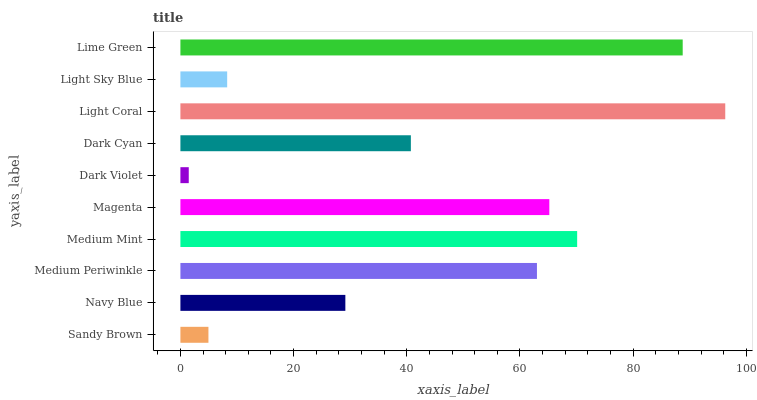Is Dark Violet the minimum?
Answer yes or no. Yes. Is Light Coral the maximum?
Answer yes or no. Yes. Is Navy Blue the minimum?
Answer yes or no. No. Is Navy Blue the maximum?
Answer yes or no. No. Is Navy Blue greater than Sandy Brown?
Answer yes or no. Yes. Is Sandy Brown less than Navy Blue?
Answer yes or no. Yes. Is Sandy Brown greater than Navy Blue?
Answer yes or no. No. Is Navy Blue less than Sandy Brown?
Answer yes or no. No. Is Medium Periwinkle the high median?
Answer yes or no. Yes. Is Dark Cyan the low median?
Answer yes or no. Yes. Is Lime Green the high median?
Answer yes or no. No. Is Medium Mint the low median?
Answer yes or no. No. 